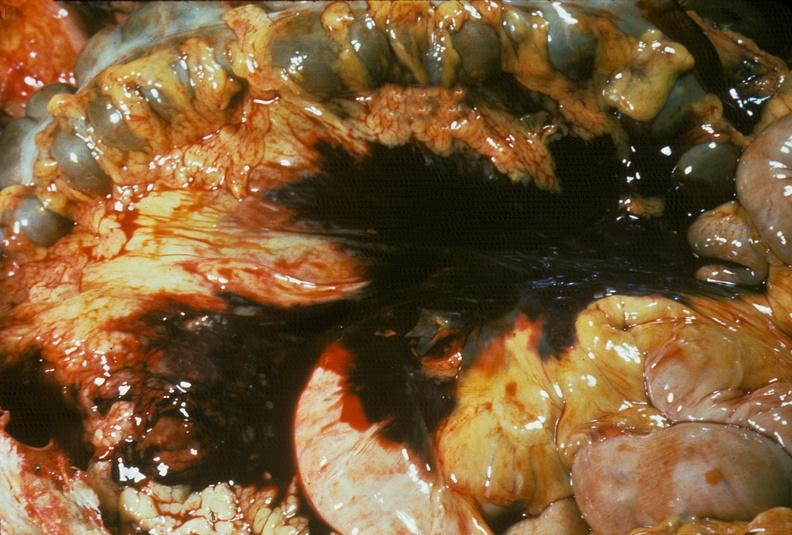s abdomen present?
Answer the question using a single word or phrase. Yes 